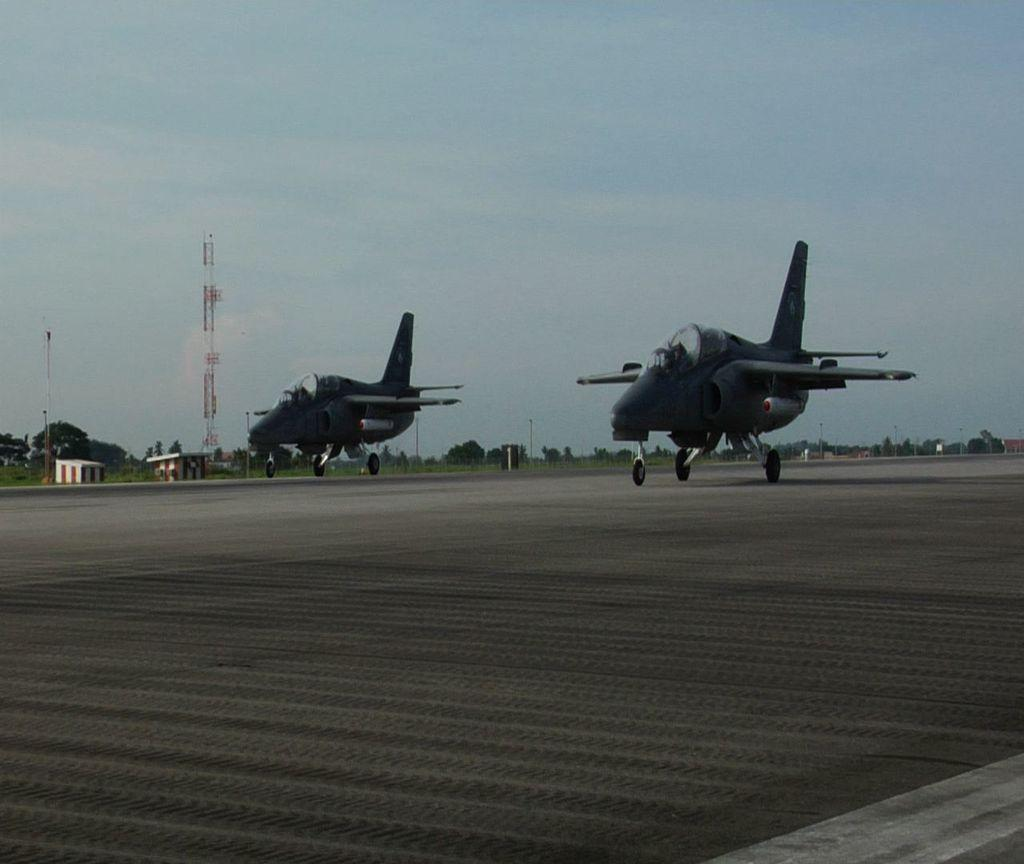What objects are on the floor in the image? There are two aeroplanes on the floor in the image. What feature do the aeroplanes have? The aeroplanes have wheels. What structure can be seen in the image? There is a tower visible in the image. What type of natural elements are present in the image? There are trees in the image. What man-made structures can be seen in the image? There are poles and sheds in the image. What is the color of the sky in the image? The sky is blue and white in color. How many bottles are visible on the tower in the image? There are no bottles visible on the tower in the image. What time does the clock show in the image? There is no clock present in the image. How many people are gathered around the aeroplanes in the image? There are no people visible in the image. 